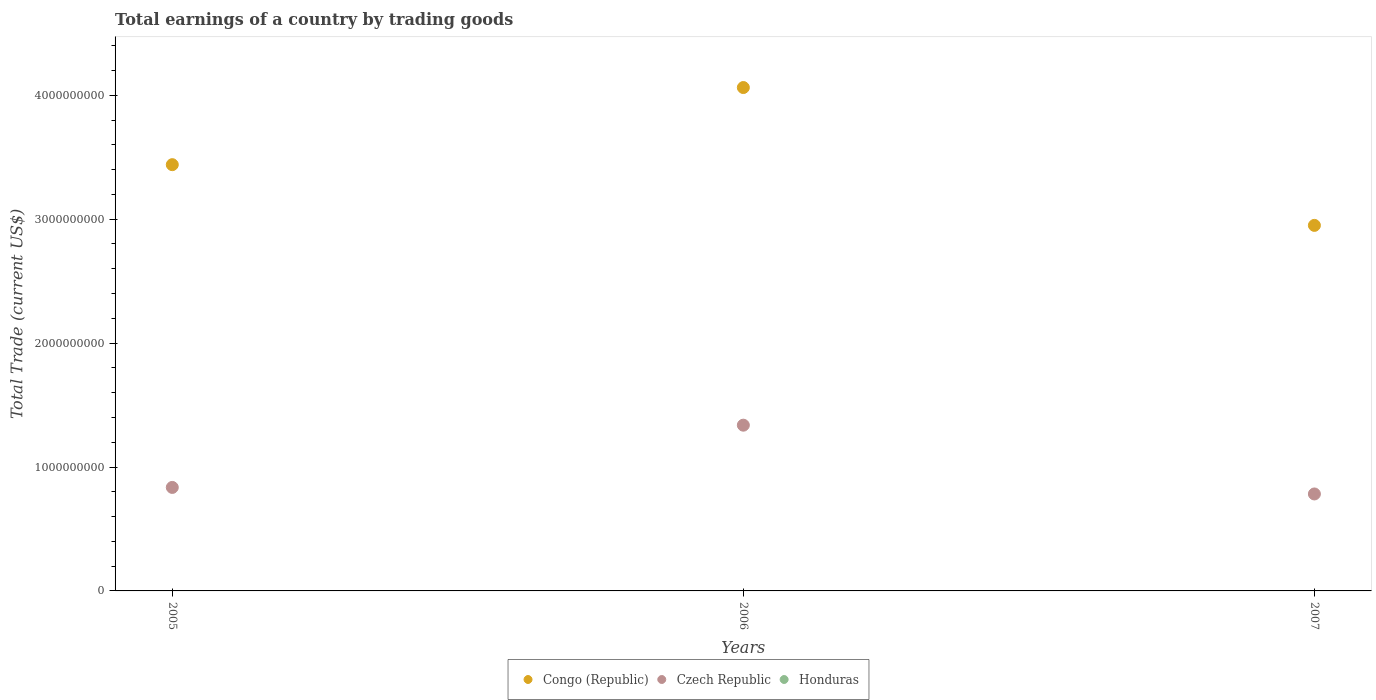What is the total earnings in Honduras in 2007?
Offer a very short reply. 0. Across all years, what is the maximum total earnings in Congo (Republic)?
Your answer should be very brief. 4.06e+09. Across all years, what is the minimum total earnings in Czech Republic?
Offer a very short reply. 7.83e+08. What is the total total earnings in Honduras in the graph?
Your response must be concise. 0. What is the difference between the total earnings in Czech Republic in 2005 and that in 2007?
Give a very brief answer. 5.27e+07. What is the difference between the total earnings in Congo (Republic) in 2005 and the total earnings in Honduras in 2007?
Give a very brief answer. 3.44e+09. What is the average total earnings in Honduras per year?
Offer a very short reply. 0. In the year 2006, what is the difference between the total earnings in Czech Republic and total earnings in Congo (Republic)?
Provide a short and direct response. -2.72e+09. In how many years, is the total earnings in Czech Republic greater than 400000000 US$?
Provide a short and direct response. 3. What is the ratio of the total earnings in Czech Republic in 2005 to that in 2007?
Your answer should be compact. 1.07. Is the total earnings in Czech Republic in 2005 less than that in 2007?
Make the answer very short. No. Is the difference between the total earnings in Czech Republic in 2006 and 2007 greater than the difference between the total earnings in Congo (Republic) in 2006 and 2007?
Make the answer very short. No. What is the difference between the highest and the second highest total earnings in Congo (Republic)?
Provide a short and direct response. 6.22e+08. What is the difference between the highest and the lowest total earnings in Czech Republic?
Keep it short and to the point. 5.55e+08. In how many years, is the total earnings in Czech Republic greater than the average total earnings in Czech Republic taken over all years?
Provide a succinct answer. 1. Does the total earnings in Congo (Republic) monotonically increase over the years?
Offer a terse response. No. What is the difference between two consecutive major ticks on the Y-axis?
Your answer should be very brief. 1.00e+09. Are the values on the major ticks of Y-axis written in scientific E-notation?
Make the answer very short. No. Does the graph contain any zero values?
Provide a short and direct response. Yes. Does the graph contain grids?
Your answer should be compact. No. Where does the legend appear in the graph?
Make the answer very short. Bottom center. How many legend labels are there?
Provide a succinct answer. 3. How are the legend labels stacked?
Offer a terse response. Horizontal. What is the title of the graph?
Your response must be concise. Total earnings of a country by trading goods. Does "Uzbekistan" appear as one of the legend labels in the graph?
Your response must be concise. No. What is the label or title of the Y-axis?
Give a very brief answer. Total Trade (current US$). What is the Total Trade (current US$) in Congo (Republic) in 2005?
Provide a short and direct response. 3.44e+09. What is the Total Trade (current US$) of Czech Republic in 2005?
Your answer should be very brief. 8.35e+08. What is the Total Trade (current US$) in Congo (Republic) in 2006?
Give a very brief answer. 4.06e+09. What is the Total Trade (current US$) of Czech Republic in 2006?
Offer a terse response. 1.34e+09. What is the Total Trade (current US$) in Congo (Republic) in 2007?
Make the answer very short. 2.95e+09. What is the Total Trade (current US$) of Czech Republic in 2007?
Ensure brevity in your answer.  7.83e+08. Across all years, what is the maximum Total Trade (current US$) in Congo (Republic)?
Your response must be concise. 4.06e+09. Across all years, what is the maximum Total Trade (current US$) of Czech Republic?
Keep it short and to the point. 1.34e+09. Across all years, what is the minimum Total Trade (current US$) in Congo (Republic)?
Keep it short and to the point. 2.95e+09. Across all years, what is the minimum Total Trade (current US$) in Czech Republic?
Give a very brief answer. 7.83e+08. What is the total Total Trade (current US$) of Congo (Republic) in the graph?
Give a very brief answer. 1.05e+1. What is the total Total Trade (current US$) of Czech Republic in the graph?
Provide a succinct answer. 2.96e+09. What is the total Total Trade (current US$) of Honduras in the graph?
Offer a very short reply. 0. What is the difference between the Total Trade (current US$) of Congo (Republic) in 2005 and that in 2006?
Provide a succinct answer. -6.22e+08. What is the difference between the Total Trade (current US$) in Czech Republic in 2005 and that in 2006?
Offer a terse response. -5.02e+08. What is the difference between the Total Trade (current US$) of Congo (Republic) in 2005 and that in 2007?
Provide a succinct answer. 4.90e+08. What is the difference between the Total Trade (current US$) in Czech Republic in 2005 and that in 2007?
Offer a very short reply. 5.27e+07. What is the difference between the Total Trade (current US$) of Congo (Republic) in 2006 and that in 2007?
Your answer should be compact. 1.11e+09. What is the difference between the Total Trade (current US$) in Czech Republic in 2006 and that in 2007?
Your answer should be very brief. 5.55e+08. What is the difference between the Total Trade (current US$) of Congo (Republic) in 2005 and the Total Trade (current US$) of Czech Republic in 2006?
Ensure brevity in your answer.  2.10e+09. What is the difference between the Total Trade (current US$) of Congo (Republic) in 2005 and the Total Trade (current US$) of Czech Republic in 2007?
Offer a terse response. 2.66e+09. What is the difference between the Total Trade (current US$) in Congo (Republic) in 2006 and the Total Trade (current US$) in Czech Republic in 2007?
Keep it short and to the point. 3.28e+09. What is the average Total Trade (current US$) of Congo (Republic) per year?
Your answer should be very brief. 3.48e+09. What is the average Total Trade (current US$) of Czech Republic per year?
Offer a very short reply. 9.85e+08. In the year 2005, what is the difference between the Total Trade (current US$) in Congo (Republic) and Total Trade (current US$) in Czech Republic?
Provide a short and direct response. 2.60e+09. In the year 2006, what is the difference between the Total Trade (current US$) in Congo (Republic) and Total Trade (current US$) in Czech Republic?
Your answer should be compact. 2.72e+09. In the year 2007, what is the difference between the Total Trade (current US$) of Congo (Republic) and Total Trade (current US$) of Czech Republic?
Provide a short and direct response. 2.17e+09. What is the ratio of the Total Trade (current US$) in Congo (Republic) in 2005 to that in 2006?
Offer a very short reply. 0.85. What is the ratio of the Total Trade (current US$) of Czech Republic in 2005 to that in 2006?
Your answer should be compact. 0.62. What is the ratio of the Total Trade (current US$) in Congo (Republic) in 2005 to that in 2007?
Keep it short and to the point. 1.17. What is the ratio of the Total Trade (current US$) of Czech Republic in 2005 to that in 2007?
Offer a terse response. 1.07. What is the ratio of the Total Trade (current US$) in Congo (Republic) in 2006 to that in 2007?
Keep it short and to the point. 1.38. What is the ratio of the Total Trade (current US$) in Czech Republic in 2006 to that in 2007?
Offer a very short reply. 1.71. What is the difference between the highest and the second highest Total Trade (current US$) of Congo (Republic)?
Ensure brevity in your answer.  6.22e+08. What is the difference between the highest and the second highest Total Trade (current US$) in Czech Republic?
Your response must be concise. 5.02e+08. What is the difference between the highest and the lowest Total Trade (current US$) of Congo (Republic)?
Keep it short and to the point. 1.11e+09. What is the difference between the highest and the lowest Total Trade (current US$) of Czech Republic?
Provide a short and direct response. 5.55e+08. 